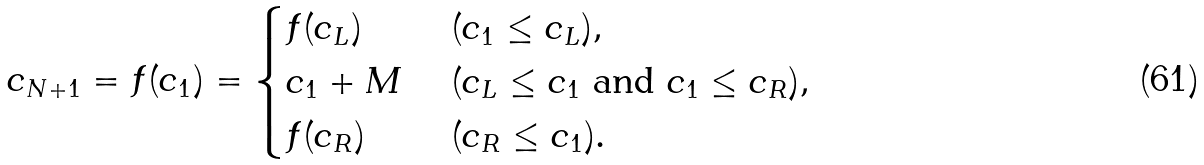Convert formula to latex. <formula><loc_0><loc_0><loc_500><loc_500>c _ { N + 1 } = f ( c _ { 1 } ) = \begin{cases} f ( c _ { L } ) \ & ( c _ { 1 } \leq c _ { L } ) , \\ c _ { 1 } + M \ & ( c _ { L } \leq c _ { 1 } \ \text {and} \ c _ { 1 } \leq c _ { R } ) , \\ f ( c _ { R } ) \ & ( c _ { R } \leq c _ { 1 } ) . \end{cases}</formula> 